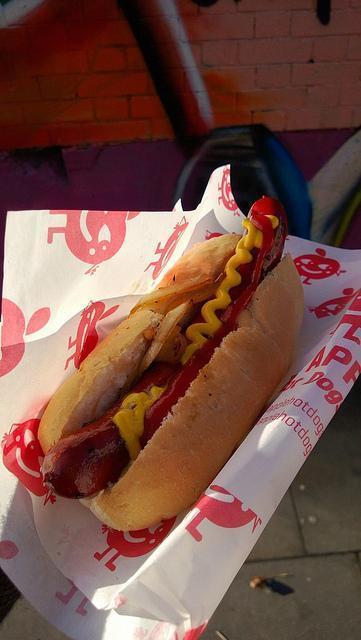How many beds are there?
Give a very brief answer. 0. 